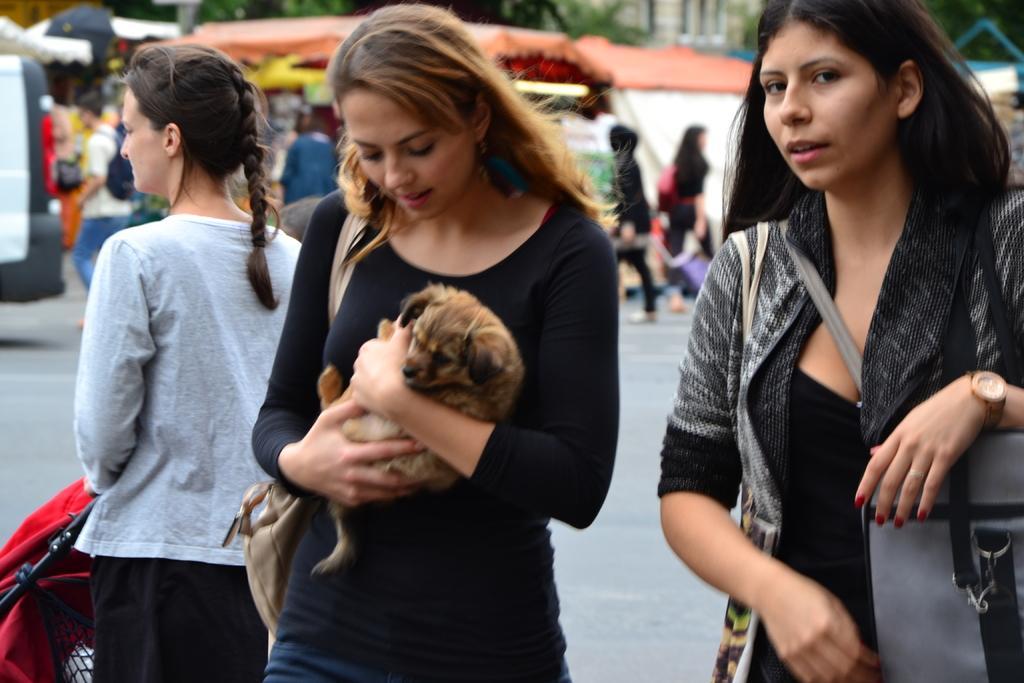Could you give a brief overview of what you see in this image? In this image, there are three women's in the foreground. In the rightmost is wearing a handbag which is grey in color and middle one is holding a dog and the leftmost is holding an umbrella. In the background, there is a tint of orange and white in color and trees are visible. There are group of people walking on the road. In the left top of the image, car is moving. In the middle of the image rightmost, building wall is visible. 